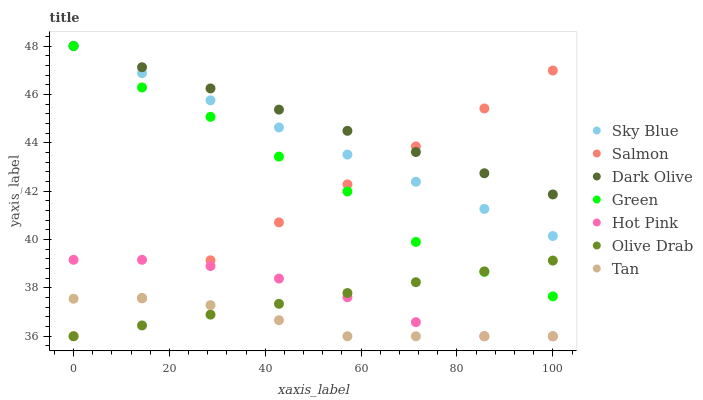Does Tan have the minimum area under the curve?
Answer yes or no. Yes. Does Dark Olive have the maximum area under the curve?
Answer yes or no. Yes. Does Salmon have the minimum area under the curve?
Answer yes or no. No. Does Salmon have the maximum area under the curve?
Answer yes or no. No. Is Sky Blue the smoothest?
Answer yes or no. Yes. Is Green the roughest?
Answer yes or no. Yes. Is Dark Olive the smoothest?
Answer yes or no. No. Is Dark Olive the roughest?
Answer yes or no. No. Does Hot Pink have the lowest value?
Answer yes or no. Yes. Does Dark Olive have the lowest value?
Answer yes or no. No. Does Sky Blue have the highest value?
Answer yes or no. Yes. Does Salmon have the highest value?
Answer yes or no. No. Is Olive Drab less than Sky Blue?
Answer yes or no. Yes. Is Dark Olive greater than Olive Drab?
Answer yes or no. Yes. Does Green intersect Dark Olive?
Answer yes or no. Yes. Is Green less than Dark Olive?
Answer yes or no. No. Is Green greater than Dark Olive?
Answer yes or no. No. Does Olive Drab intersect Sky Blue?
Answer yes or no. No. 